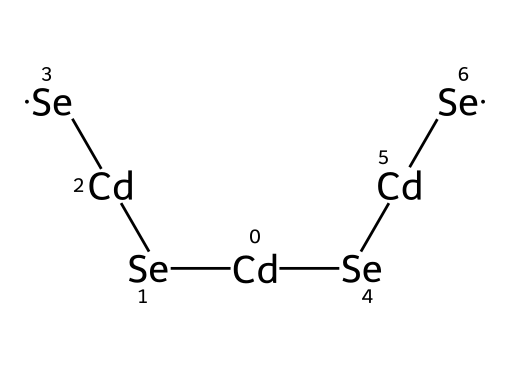What is the central atom in the structure? The structure has cadmium atoms bonded to selenium atoms, identifying cadmium as the central atom.
Answer: cadmium How many selenium atoms are present in the structure? Counting the selenium atoms in the structure, there are four selenium atoms connected to cadmium.
Answer: four What type of compound are cadmium selenide quantum dots? Cadmium selenide quantum dots belong to the category of semiconductor materials, which are essential for their electronic properties.
Answer: semiconductor What is the main feature of the bonding in this chemical structure? The bonding in this structure primarily comprises covalent bonds between cadmium and selenium, indicating a strong interaction.
Answer: covalent What is the significance of the quantum dots in displays? Quantum dots improve color accuracy and brightness in QLED displays due to their tunable optical properties based on size.
Answer: color accuracy How do the properties of cadmium selenide affect its use in technology? The unique properties of cadmium selenide, such as strong light absorption and photoluminescence, make it ideal for advanced display technologies.
Answer: photoluminescence What is the role of quantum dots in light emission? Quantum dots emit light when excited, a property arising from their quantum mechanical nature and size-dependent energy levels.
Answer: emit light 